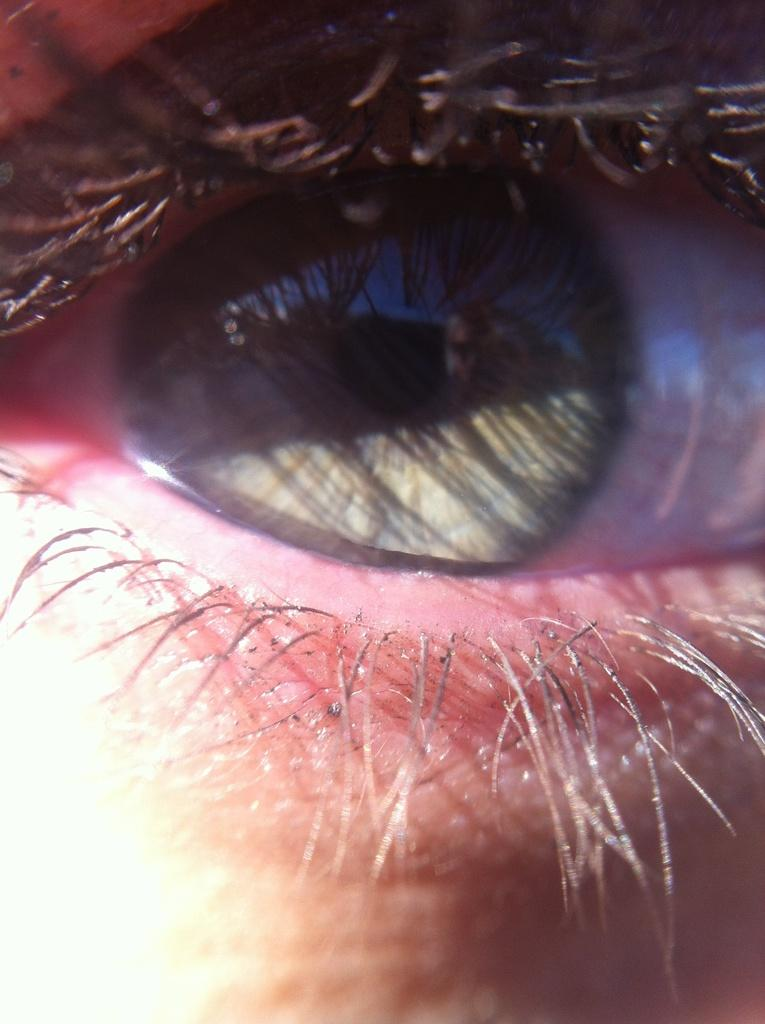What is the main subject of the picture? The main subject of the picture is an eye. What feature of the eye can be seen in the picture? Eyelashes are visible in the picture. What type of country is depicted in the picture? There is no country depicted in the picture; it features an eye with visible eyelashes. 